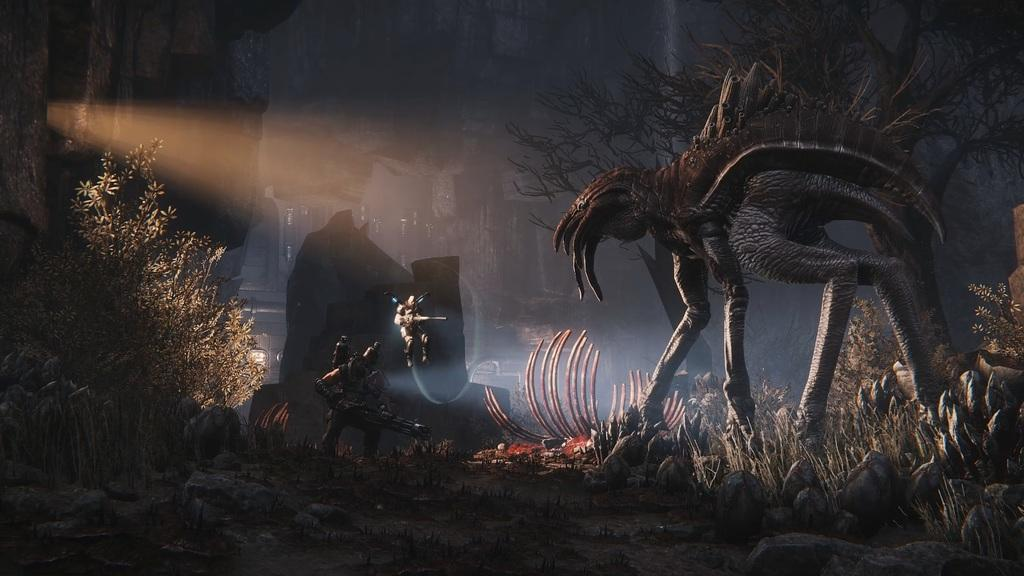What type of living creature is present in the image? There is an animal in the picture. How many people are in the image? There are two persons standing in the picture. What other object can be seen in the image? There is a plant in the picture. What can be seen in the distance in the image? There are buildings in the background of the picture. What phase of the moon is visible in the image? There is no moon visible in the image. What is the aftermath of the event that occurred in the image? There is no event or aftermath mentioned in the image; it simply shows an animal, two persons, a plant, and buildings in the background. 